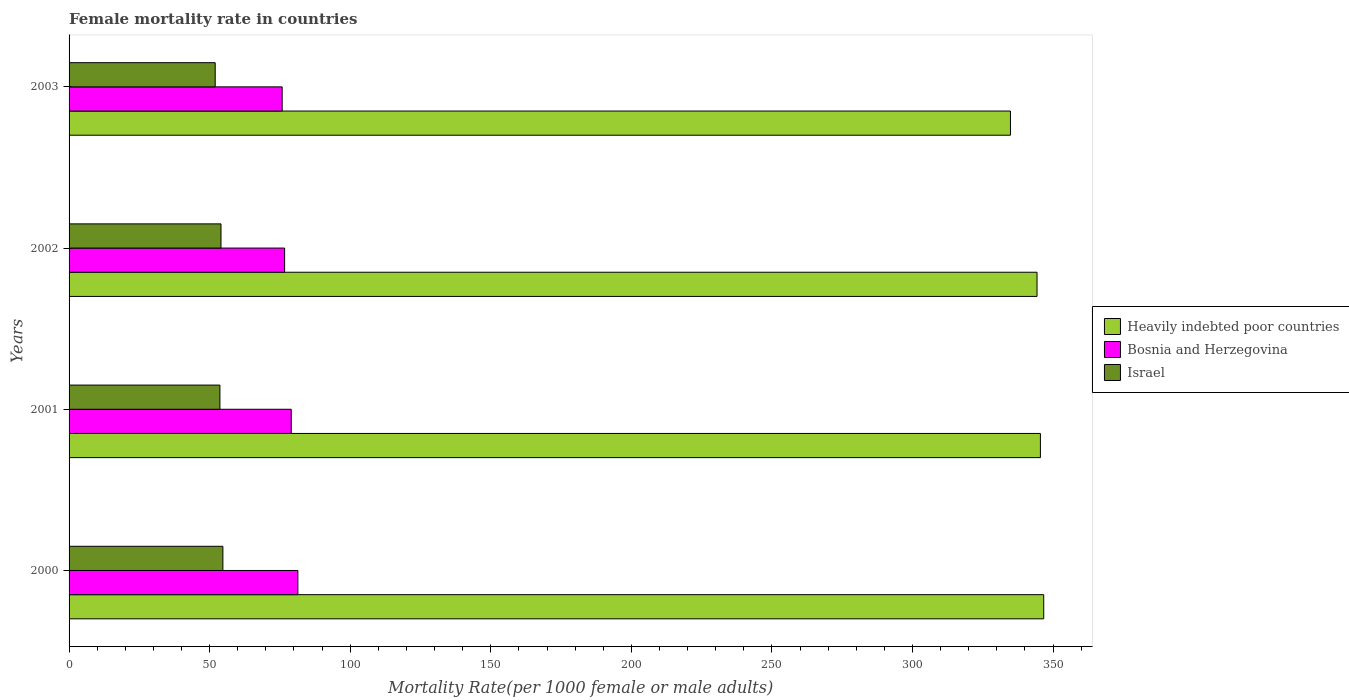How many different coloured bars are there?
Ensure brevity in your answer.  3. How many groups of bars are there?
Keep it short and to the point. 4. Are the number of bars per tick equal to the number of legend labels?
Give a very brief answer. Yes. How many bars are there on the 2nd tick from the bottom?
Your answer should be very brief. 3. In how many cases, is the number of bars for a given year not equal to the number of legend labels?
Your answer should be very brief. 0. What is the female mortality rate in Heavily indebted poor countries in 2001?
Give a very brief answer. 345.48. Across all years, what is the maximum female mortality rate in Israel?
Offer a terse response. 54.71. Across all years, what is the minimum female mortality rate in Israel?
Offer a terse response. 51.97. In which year was the female mortality rate in Bosnia and Herzegovina maximum?
Offer a very short reply. 2000. In which year was the female mortality rate in Heavily indebted poor countries minimum?
Your response must be concise. 2003. What is the total female mortality rate in Heavily indebted poor countries in the graph?
Make the answer very short. 1371.27. What is the difference between the female mortality rate in Heavily indebted poor countries in 2002 and that in 2003?
Offer a terse response. 9.45. What is the difference between the female mortality rate in Israel in 2001 and the female mortality rate in Heavily indebted poor countries in 2003?
Make the answer very short. -281.18. What is the average female mortality rate in Heavily indebted poor countries per year?
Your answer should be very brief. 342.82. In the year 2001, what is the difference between the female mortality rate in Heavily indebted poor countries and female mortality rate in Israel?
Provide a short and direct response. 291.83. In how many years, is the female mortality rate in Bosnia and Herzegovina greater than 80 ?
Ensure brevity in your answer.  1. What is the ratio of the female mortality rate in Israel in 2001 to that in 2002?
Your response must be concise. 0.99. What is the difference between the highest and the second highest female mortality rate in Bosnia and Herzegovina?
Your response must be concise. 2.36. What is the difference between the highest and the lowest female mortality rate in Israel?
Your answer should be very brief. 2.74. In how many years, is the female mortality rate in Israel greater than the average female mortality rate in Israel taken over all years?
Your answer should be compact. 3. What does the 3rd bar from the top in 2000 represents?
Provide a short and direct response. Heavily indebted poor countries. What does the 2nd bar from the bottom in 2000 represents?
Ensure brevity in your answer.  Bosnia and Herzegovina. Does the graph contain grids?
Give a very brief answer. No. Where does the legend appear in the graph?
Your response must be concise. Center right. What is the title of the graph?
Ensure brevity in your answer.  Female mortality rate in countries. Does "St. Kitts and Nevis" appear as one of the legend labels in the graph?
Your response must be concise. No. What is the label or title of the X-axis?
Give a very brief answer. Mortality Rate(per 1000 female or male adults). What is the Mortality Rate(per 1000 female or male adults) in Heavily indebted poor countries in 2000?
Provide a succinct answer. 346.66. What is the Mortality Rate(per 1000 female or male adults) of Bosnia and Herzegovina in 2000?
Offer a very short reply. 81.38. What is the Mortality Rate(per 1000 female or male adults) of Israel in 2000?
Provide a short and direct response. 54.71. What is the Mortality Rate(per 1000 female or male adults) of Heavily indebted poor countries in 2001?
Provide a succinct answer. 345.48. What is the Mortality Rate(per 1000 female or male adults) of Bosnia and Herzegovina in 2001?
Ensure brevity in your answer.  79.03. What is the Mortality Rate(per 1000 female or male adults) of Israel in 2001?
Keep it short and to the point. 53.65. What is the Mortality Rate(per 1000 female or male adults) of Heavily indebted poor countries in 2002?
Provide a succinct answer. 344.28. What is the Mortality Rate(per 1000 female or male adults) of Bosnia and Herzegovina in 2002?
Provide a succinct answer. 76.67. What is the Mortality Rate(per 1000 female or male adults) in Israel in 2002?
Ensure brevity in your answer.  54.03. What is the Mortality Rate(per 1000 female or male adults) of Heavily indebted poor countries in 2003?
Your answer should be compact. 334.84. What is the Mortality Rate(per 1000 female or male adults) of Bosnia and Herzegovina in 2003?
Your response must be concise. 75.8. What is the Mortality Rate(per 1000 female or male adults) of Israel in 2003?
Offer a terse response. 51.97. Across all years, what is the maximum Mortality Rate(per 1000 female or male adults) in Heavily indebted poor countries?
Ensure brevity in your answer.  346.66. Across all years, what is the maximum Mortality Rate(per 1000 female or male adults) in Bosnia and Herzegovina?
Your response must be concise. 81.38. Across all years, what is the maximum Mortality Rate(per 1000 female or male adults) of Israel?
Provide a succinct answer. 54.71. Across all years, what is the minimum Mortality Rate(per 1000 female or male adults) in Heavily indebted poor countries?
Keep it short and to the point. 334.84. Across all years, what is the minimum Mortality Rate(per 1000 female or male adults) of Bosnia and Herzegovina?
Keep it short and to the point. 75.8. Across all years, what is the minimum Mortality Rate(per 1000 female or male adults) in Israel?
Offer a terse response. 51.97. What is the total Mortality Rate(per 1000 female or male adults) in Heavily indebted poor countries in the graph?
Make the answer very short. 1371.27. What is the total Mortality Rate(per 1000 female or male adults) of Bosnia and Herzegovina in the graph?
Provide a short and direct response. 312.88. What is the total Mortality Rate(per 1000 female or male adults) in Israel in the graph?
Your answer should be very brief. 214.37. What is the difference between the Mortality Rate(per 1000 female or male adults) in Heavily indebted poor countries in 2000 and that in 2001?
Make the answer very short. 1.18. What is the difference between the Mortality Rate(per 1000 female or male adults) in Bosnia and Herzegovina in 2000 and that in 2001?
Give a very brief answer. 2.36. What is the difference between the Mortality Rate(per 1000 female or male adults) of Israel in 2000 and that in 2001?
Offer a terse response. 1.06. What is the difference between the Mortality Rate(per 1000 female or male adults) in Heavily indebted poor countries in 2000 and that in 2002?
Make the answer very short. 2.38. What is the difference between the Mortality Rate(per 1000 female or male adults) in Bosnia and Herzegovina in 2000 and that in 2002?
Offer a terse response. 4.72. What is the difference between the Mortality Rate(per 1000 female or male adults) in Israel in 2000 and that in 2002?
Offer a terse response. 0.68. What is the difference between the Mortality Rate(per 1000 female or male adults) in Heavily indebted poor countries in 2000 and that in 2003?
Provide a succinct answer. 11.82. What is the difference between the Mortality Rate(per 1000 female or male adults) of Bosnia and Herzegovina in 2000 and that in 2003?
Your response must be concise. 5.59. What is the difference between the Mortality Rate(per 1000 female or male adults) in Israel in 2000 and that in 2003?
Your answer should be very brief. 2.74. What is the difference between the Mortality Rate(per 1000 female or male adults) in Heavily indebted poor countries in 2001 and that in 2002?
Provide a short and direct response. 1.2. What is the difference between the Mortality Rate(per 1000 female or male adults) in Bosnia and Herzegovina in 2001 and that in 2002?
Ensure brevity in your answer.  2.36. What is the difference between the Mortality Rate(per 1000 female or male adults) of Israel in 2001 and that in 2002?
Your response must be concise. -0.38. What is the difference between the Mortality Rate(per 1000 female or male adults) of Heavily indebted poor countries in 2001 and that in 2003?
Give a very brief answer. 10.65. What is the difference between the Mortality Rate(per 1000 female or male adults) of Bosnia and Herzegovina in 2001 and that in 2003?
Provide a short and direct response. 3.23. What is the difference between the Mortality Rate(per 1000 female or male adults) in Israel in 2001 and that in 2003?
Your answer should be very brief. 1.68. What is the difference between the Mortality Rate(per 1000 female or male adults) in Heavily indebted poor countries in 2002 and that in 2003?
Your answer should be compact. 9.45. What is the difference between the Mortality Rate(per 1000 female or male adults) of Bosnia and Herzegovina in 2002 and that in 2003?
Keep it short and to the point. 0.87. What is the difference between the Mortality Rate(per 1000 female or male adults) of Israel in 2002 and that in 2003?
Ensure brevity in your answer.  2.06. What is the difference between the Mortality Rate(per 1000 female or male adults) of Heavily indebted poor countries in 2000 and the Mortality Rate(per 1000 female or male adults) of Bosnia and Herzegovina in 2001?
Provide a short and direct response. 267.64. What is the difference between the Mortality Rate(per 1000 female or male adults) of Heavily indebted poor countries in 2000 and the Mortality Rate(per 1000 female or male adults) of Israel in 2001?
Keep it short and to the point. 293.01. What is the difference between the Mortality Rate(per 1000 female or male adults) of Bosnia and Herzegovina in 2000 and the Mortality Rate(per 1000 female or male adults) of Israel in 2001?
Make the answer very short. 27.73. What is the difference between the Mortality Rate(per 1000 female or male adults) in Heavily indebted poor countries in 2000 and the Mortality Rate(per 1000 female or male adults) in Bosnia and Herzegovina in 2002?
Make the answer very short. 269.99. What is the difference between the Mortality Rate(per 1000 female or male adults) of Heavily indebted poor countries in 2000 and the Mortality Rate(per 1000 female or male adults) of Israel in 2002?
Your response must be concise. 292.63. What is the difference between the Mortality Rate(per 1000 female or male adults) in Bosnia and Herzegovina in 2000 and the Mortality Rate(per 1000 female or male adults) in Israel in 2002?
Provide a short and direct response. 27.35. What is the difference between the Mortality Rate(per 1000 female or male adults) of Heavily indebted poor countries in 2000 and the Mortality Rate(per 1000 female or male adults) of Bosnia and Herzegovina in 2003?
Provide a succinct answer. 270.86. What is the difference between the Mortality Rate(per 1000 female or male adults) of Heavily indebted poor countries in 2000 and the Mortality Rate(per 1000 female or male adults) of Israel in 2003?
Make the answer very short. 294.69. What is the difference between the Mortality Rate(per 1000 female or male adults) of Bosnia and Herzegovina in 2000 and the Mortality Rate(per 1000 female or male adults) of Israel in 2003?
Ensure brevity in your answer.  29.41. What is the difference between the Mortality Rate(per 1000 female or male adults) in Heavily indebted poor countries in 2001 and the Mortality Rate(per 1000 female or male adults) in Bosnia and Herzegovina in 2002?
Ensure brevity in your answer.  268.82. What is the difference between the Mortality Rate(per 1000 female or male adults) in Heavily indebted poor countries in 2001 and the Mortality Rate(per 1000 female or male adults) in Israel in 2002?
Provide a succinct answer. 291.45. What is the difference between the Mortality Rate(per 1000 female or male adults) of Bosnia and Herzegovina in 2001 and the Mortality Rate(per 1000 female or male adults) of Israel in 2002?
Your answer should be very brief. 24.99. What is the difference between the Mortality Rate(per 1000 female or male adults) in Heavily indebted poor countries in 2001 and the Mortality Rate(per 1000 female or male adults) in Bosnia and Herzegovina in 2003?
Ensure brevity in your answer.  269.69. What is the difference between the Mortality Rate(per 1000 female or male adults) of Heavily indebted poor countries in 2001 and the Mortality Rate(per 1000 female or male adults) of Israel in 2003?
Provide a succinct answer. 293.51. What is the difference between the Mortality Rate(per 1000 female or male adults) in Bosnia and Herzegovina in 2001 and the Mortality Rate(per 1000 female or male adults) in Israel in 2003?
Your response must be concise. 27.05. What is the difference between the Mortality Rate(per 1000 female or male adults) of Heavily indebted poor countries in 2002 and the Mortality Rate(per 1000 female or male adults) of Bosnia and Herzegovina in 2003?
Keep it short and to the point. 268.49. What is the difference between the Mortality Rate(per 1000 female or male adults) in Heavily indebted poor countries in 2002 and the Mortality Rate(per 1000 female or male adults) in Israel in 2003?
Offer a very short reply. 292.31. What is the difference between the Mortality Rate(per 1000 female or male adults) of Bosnia and Herzegovina in 2002 and the Mortality Rate(per 1000 female or male adults) of Israel in 2003?
Keep it short and to the point. 24.69. What is the average Mortality Rate(per 1000 female or male adults) of Heavily indebted poor countries per year?
Make the answer very short. 342.82. What is the average Mortality Rate(per 1000 female or male adults) of Bosnia and Herzegovina per year?
Provide a succinct answer. 78.22. What is the average Mortality Rate(per 1000 female or male adults) of Israel per year?
Offer a very short reply. 53.59. In the year 2000, what is the difference between the Mortality Rate(per 1000 female or male adults) of Heavily indebted poor countries and Mortality Rate(per 1000 female or male adults) of Bosnia and Herzegovina?
Your answer should be very brief. 265.28. In the year 2000, what is the difference between the Mortality Rate(per 1000 female or male adults) in Heavily indebted poor countries and Mortality Rate(per 1000 female or male adults) in Israel?
Provide a succinct answer. 291.95. In the year 2000, what is the difference between the Mortality Rate(per 1000 female or male adults) in Bosnia and Herzegovina and Mortality Rate(per 1000 female or male adults) in Israel?
Ensure brevity in your answer.  26.67. In the year 2001, what is the difference between the Mortality Rate(per 1000 female or male adults) in Heavily indebted poor countries and Mortality Rate(per 1000 female or male adults) in Bosnia and Herzegovina?
Your answer should be very brief. 266.46. In the year 2001, what is the difference between the Mortality Rate(per 1000 female or male adults) of Heavily indebted poor countries and Mortality Rate(per 1000 female or male adults) of Israel?
Make the answer very short. 291.83. In the year 2001, what is the difference between the Mortality Rate(per 1000 female or male adults) in Bosnia and Herzegovina and Mortality Rate(per 1000 female or male adults) in Israel?
Give a very brief answer. 25.37. In the year 2002, what is the difference between the Mortality Rate(per 1000 female or male adults) of Heavily indebted poor countries and Mortality Rate(per 1000 female or male adults) of Bosnia and Herzegovina?
Offer a very short reply. 267.62. In the year 2002, what is the difference between the Mortality Rate(per 1000 female or male adults) in Heavily indebted poor countries and Mortality Rate(per 1000 female or male adults) in Israel?
Your answer should be compact. 290.25. In the year 2002, what is the difference between the Mortality Rate(per 1000 female or male adults) in Bosnia and Herzegovina and Mortality Rate(per 1000 female or male adults) in Israel?
Offer a very short reply. 22.64. In the year 2003, what is the difference between the Mortality Rate(per 1000 female or male adults) in Heavily indebted poor countries and Mortality Rate(per 1000 female or male adults) in Bosnia and Herzegovina?
Make the answer very short. 259.04. In the year 2003, what is the difference between the Mortality Rate(per 1000 female or male adults) of Heavily indebted poor countries and Mortality Rate(per 1000 female or male adults) of Israel?
Offer a very short reply. 282.86. In the year 2003, what is the difference between the Mortality Rate(per 1000 female or male adults) in Bosnia and Herzegovina and Mortality Rate(per 1000 female or male adults) in Israel?
Ensure brevity in your answer.  23.82. What is the ratio of the Mortality Rate(per 1000 female or male adults) in Heavily indebted poor countries in 2000 to that in 2001?
Keep it short and to the point. 1. What is the ratio of the Mortality Rate(per 1000 female or male adults) in Bosnia and Herzegovina in 2000 to that in 2001?
Give a very brief answer. 1.03. What is the ratio of the Mortality Rate(per 1000 female or male adults) of Israel in 2000 to that in 2001?
Your response must be concise. 1.02. What is the ratio of the Mortality Rate(per 1000 female or male adults) of Heavily indebted poor countries in 2000 to that in 2002?
Provide a short and direct response. 1.01. What is the ratio of the Mortality Rate(per 1000 female or male adults) of Bosnia and Herzegovina in 2000 to that in 2002?
Your answer should be very brief. 1.06. What is the ratio of the Mortality Rate(per 1000 female or male adults) of Israel in 2000 to that in 2002?
Offer a very short reply. 1.01. What is the ratio of the Mortality Rate(per 1000 female or male adults) of Heavily indebted poor countries in 2000 to that in 2003?
Offer a terse response. 1.04. What is the ratio of the Mortality Rate(per 1000 female or male adults) in Bosnia and Herzegovina in 2000 to that in 2003?
Your answer should be very brief. 1.07. What is the ratio of the Mortality Rate(per 1000 female or male adults) of Israel in 2000 to that in 2003?
Your response must be concise. 1.05. What is the ratio of the Mortality Rate(per 1000 female or male adults) in Heavily indebted poor countries in 2001 to that in 2002?
Keep it short and to the point. 1. What is the ratio of the Mortality Rate(per 1000 female or male adults) of Bosnia and Herzegovina in 2001 to that in 2002?
Offer a terse response. 1.03. What is the ratio of the Mortality Rate(per 1000 female or male adults) in Israel in 2001 to that in 2002?
Ensure brevity in your answer.  0.99. What is the ratio of the Mortality Rate(per 1000 female or male adults) of Heavily indebted poor countries in 2001 to that in 2003?
Your response must be concise. 1.03. What is the ratio of the Mortality Rate(per 1000 female or male adults) in Bosnia and Herzegovina in 2001 to that in 2003?
Your answer should be very brief. 1.04. What is the ratio of the Mortality Rate(per 1000 female or male adults) of Israel in 2001 to that in 2003?
Offer a terse response. 1.03. What is the ratio of the Mortality Rate(per 1000 female or male adults) of Heavily indebted poor countries in 2002 to that in 2003?
Keep it short and to the point. 1.03. What is the ratio of the Mortality Rate(per 1000 female or male adults) in Bosnia and Herzegovina in 2002 to that in 2003?
Keep it short and to the point. 1.01. What is the ratio of the Mortality Rate(per 1000 female or male adults) of Israel in 2002 to that in 2003?
Ensure brevity in your answer.  1.04. What is the difference between the highest and the second highest Mortality Rate(per 1000 female or male adults) of Heavily indebted poor countries?
Your response must be concise. 1.18. What is the difference between the highest and the second highest Mortality Rate(per 1000 female or male adults) in Bosnia and Herzegovina?
Provide a succinct answer. 2.36. What is the difference between the highest and the second highest Mortality Rate(per 1000 female or male adults) of Israel?
Provide a succinct answer. 0.68. What is the difference between the highest and the lowest Mortality Rate(per 1000 female or male adults) in Heavily indebted poor countries?
Provide a short and direct response. 11.82. What is the difference between the highest and the lowest Mortality Rate(per 1000 female or male adults) of Bosnia and Herzegovina?
Ensure brevity in your answer.  5.59. What is the difference between the highest and the lowest Mortality Rate(per 1000 female or male adults) of Israel?
Ensure brevity in your answer.  2.74. 